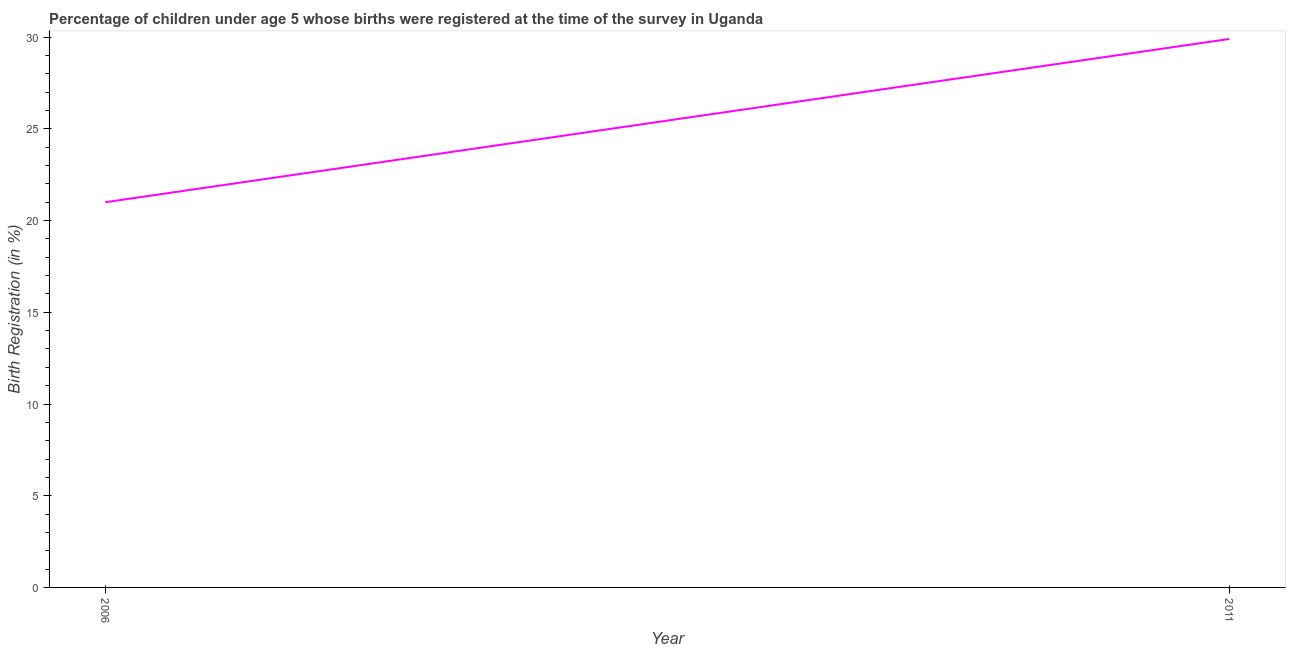What is the birth registration in 2011?
Give a very brief answer. 29.9. Across all years, what is the maximum birth registration?
Keep it short and to the point. 29.9. In which year was the birth registration maximum?
Give a very brief answer. 2011. What is the sum of the birth registration?
Make the answer very short. 50.9. What is the difference between the birth registration in 2006 and 2011?
Offer a terse response. -8.9. What is the average birth registration per year?
Keep it short and to the point. 25.45. What is the median birth registration?
Your answer should be compact. 25.45. Do a majority of the years between 2006 and 2011 (inclusive) have birth registration greater than 26 %?
Provide a succinct answer. No. What is the ratio of the birth registration in 2006 to that in 2011?
Make the answer very short. 0.7. Is the birth registration in 2006 less than that in 2011?
Ensure brevity in your answer.  Yes. Does the birth registration monotonically increase over the years?
Give a very brief answer. Yes. Are the values on the major ticks of Y-axis written in scientific E-notation?
Keep it short and to the point. No. Does the graph contain grids?
Ensure brevity in your answer.  No. What is the title of the graph?
Provide a short and direct response. Percentage of children under age 5 whose births were registered at the time of the survey in Uganda. What is the label or title of the Y-axis?
Keep it short and to the point. Birth Registration (in %). What is the Birth Registration (in %) in 2011?
Offer a very short reply. 29.9. What is the difference between the Birth Registration (in %) in 2006 and 2011?
Make the answer very short. -8.9. What is the ratio of the Birth Registration (in %) in 2006 to that in 2011?
Give a very brief answer. 0.7. 